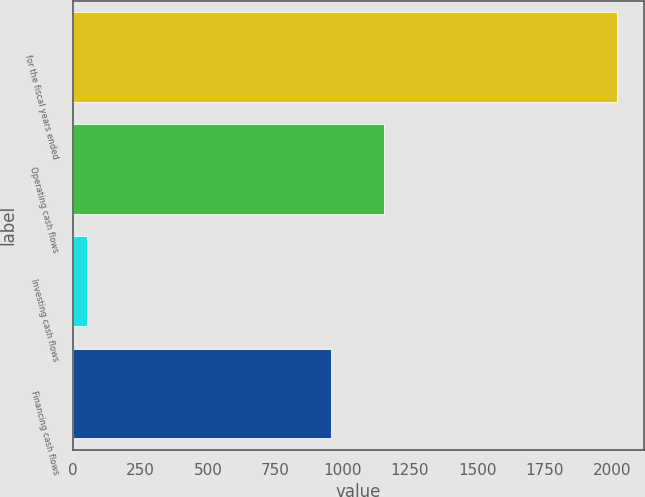<chart> <loc_0><loc_0><loc_500><loc_500><bar_chart><fcel>for the fiscal years ended<fcel>Operating cash flows<fcel>Investing cash flows<fcel>Financing cash flows<nl><fcel>2017<fcel>1152.5<fcel>52<fcel>956<nl></chart> 